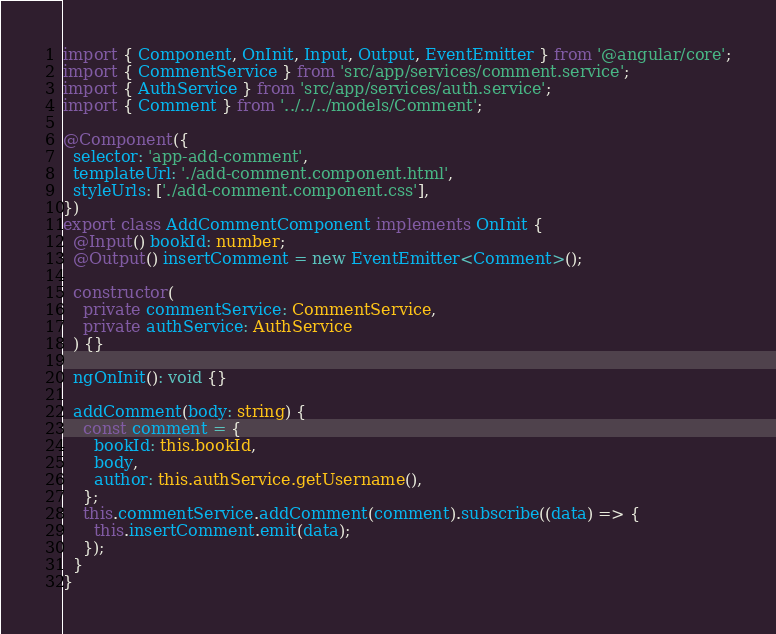<code> <loc_0><loc_0><loc_500><loc_500><_TypeScript_>import { Component, OnInit, Input, Output, EventEmitter } from '@angular/core';
import { CommentService } from 'src/app/services/comment.service';
import { AuthService } from 'src/app/services/auth.service';
import { Comment } from '../../../models/Comment';

@Component({
  selector: 'app-add-comment',
  templateUrl: './add-comment.component.html',
  styleUrls: ['./add-comment.component.css'],
})
export class AddCommentComponent implements OnInit {
  @Input() bookId: number;
  @Output() insertComment = new EventEmitter<Comment>();

  constructor(
    private commentService: CommentService,
    private authService: AuthService
  ) {}

  ngOnInit(): void {}

  addComment(body: string) {
    const comment = {
      bookId: this.bookId,
      body,
      author: this.authService.getUsername(),
    };
    this.commentService.addComment(comment).subscribe((data) => {
      this.insertComment.emit(data);
    });
  }
}
</code> 